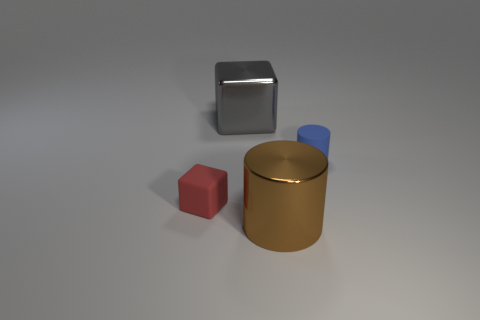There is a brown object that is the same size as the gray metallic cube; what shape is it?
Your answer should be compact. Cylinder. Is there anything else that is the same size as the metallic cube?
Keep it short and to the point. Yes. There is a big block that is left of the big object in front of the gray object; what is it made of?
Your answer should be very brief. Metal. Is the size of the blue matte cylinder the same as the brown object?
Keep it short and to the point. No. How many objects are either cubes behind the small blue cylinder or large gray things?
Provide a succinct answer. 1. The tiny rubber object behind the rubber thing to the left of the big brown object is what shape?
Your response must be concise. Cylinder. There is a blue thing; does it have the same size as the metal object that is right of the metallic block?
Keep it short and to the point. No. There is a big thing left of the brown metal object; what is it made of?
Your answer should be compact. Metal. What number of objects are to the left of the blue thing and behind the large metallic cylinder?
Offer a terse response. 2. There is a blue cylinder that is the same size as the red block; what material is it?
Offer a terse response. Rubber. 